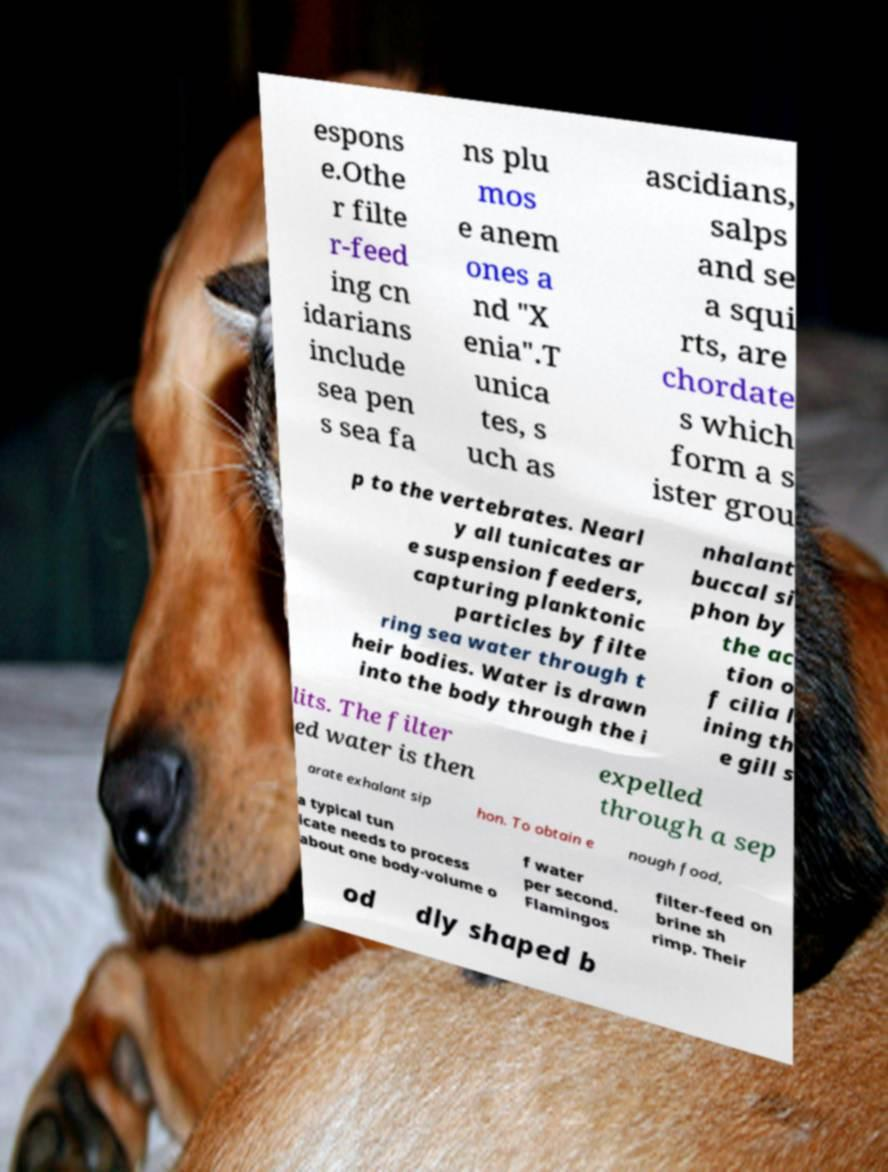I need the written content from this picture converted into text. Can you do that? espons e.Othe r filte r-feed ing cn idarians include sea pen s sea fa ns plu mos e anem ones a nd "X enia".T unica tes, s uch as ascidians, salps and se a squi rts, are chordate s which form a s ister grou p to the vertebrates. Nearl y all tunicates ar e suspension feeders, capturing planktonic particles by filte ring sea water through t heir bodies. Water is drawn into the body through the i nhalant buccal si phon by the ac tion o f cilia l ining th e gill s lits. The filter ed water is then expelled through a sep arate exhalant sip hon. To obtain e nough food, a typical tun icate needs to process about one body-volume o f water per second. Flamingos filter-feed on brine sh rimp. Their od dly shaped b 